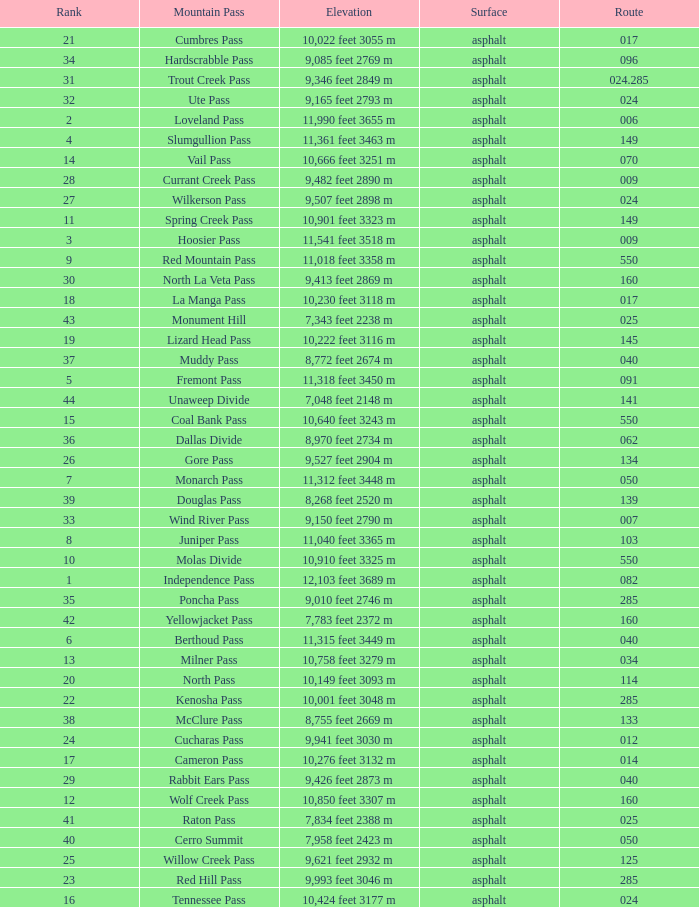What is the Elevation of the mountain on Route 62? 8,970 feet 2734 m. 